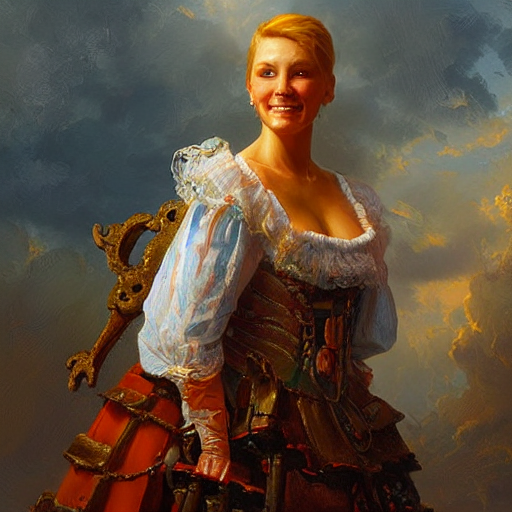Could you interpret the choice of colors in the image and their impact on the overall composition? The choice of warm golds, rich reds, and calming blues create a harmonious composition, imbuing the image with a sense of nobility and grace. The colors also serve to highlight the central figure and draw attention to the fine details of the clothing. 